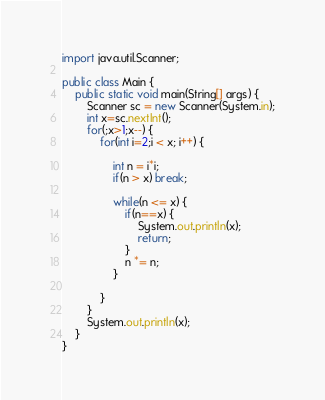Convert code to text. <code><loc_0><loc_0><loc_500><loc_500><_Java_>import java.util.Scanner;

public class Main {
	public static void main(String[] args) {
		Scanner sc = new Scanner(System.in);
		int x=sc.nextInt();
		for(;x>1;x--) {
			for(int i=2;i < x; i++) {

				int n = i*i;
				if(n > x) break;

				while(n <= x) {
					if(n==x) {
						System.out.println(x);
						return;
					}
					n *= n;
				}

			}
		}
		System.out.println(x);
	}
}
</code> 